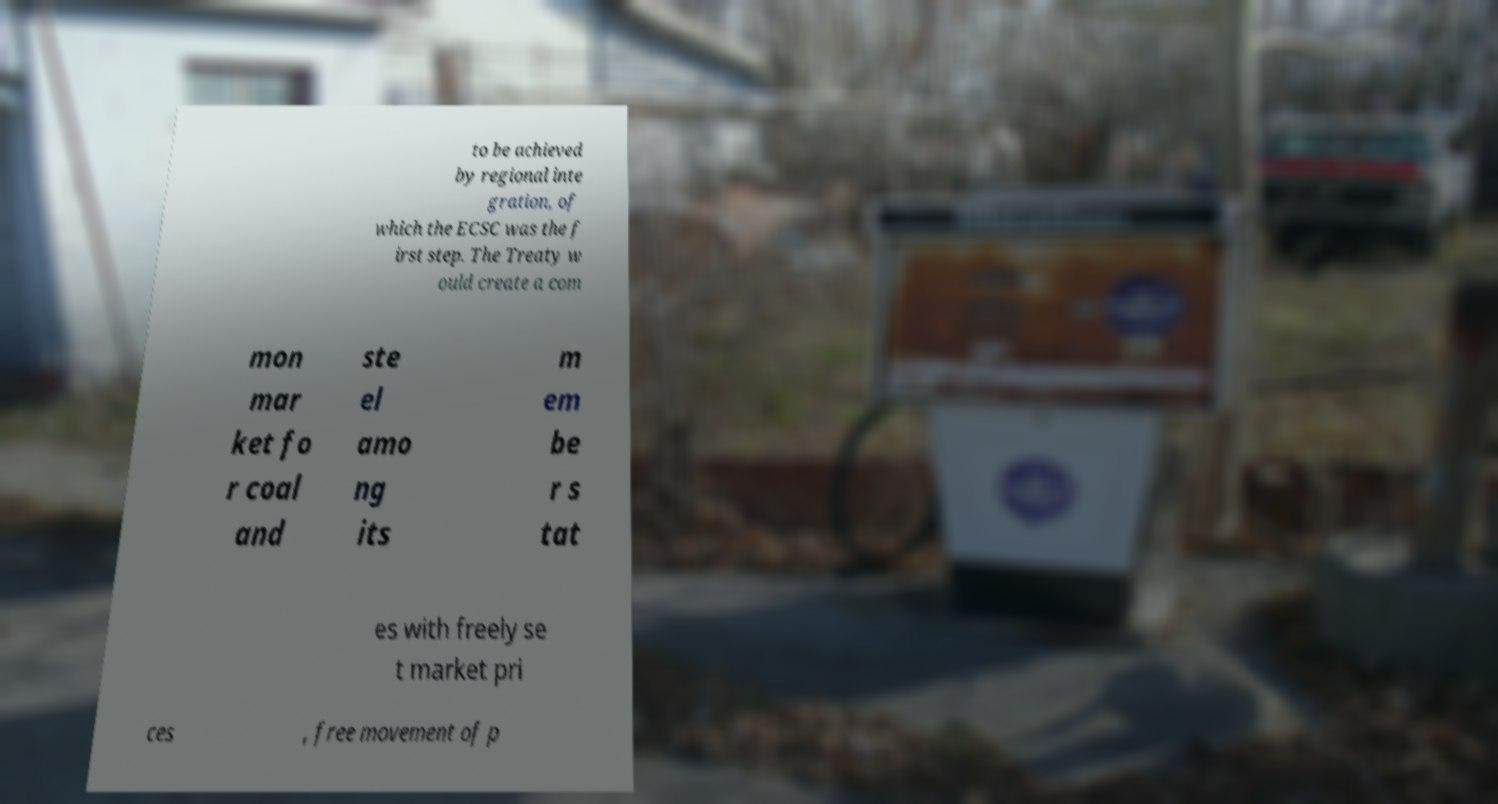There's text embedded in this image that I need extracted. Can you transcribe it verbatim? to be achieved by regional inte gration, of which the ECSC was the f irst step. The Treaty w ould create a com mon mar ket fo r coal and ste el amo ng its m em be r s tat es with freely se t market pri ces , free movement of p 